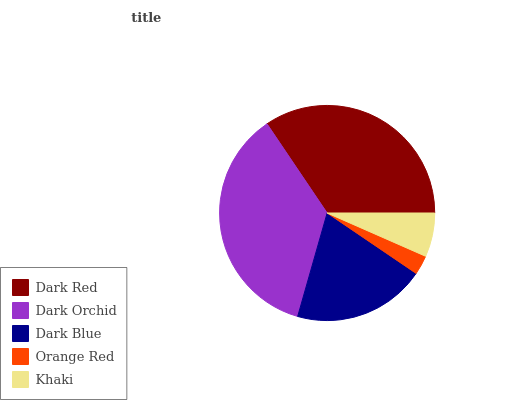Is Orange Red the minimum?
Answer yes or no. Yes. Is Dark Orchid the maximum?
Answer yes or no. Yes. Is Dark Blue the minimum?
Answer yes or no. No. Is Dark Blue the maximum?
Answer yes or no. No. Is Dark Orchid greater than Dark Blue?
Answer yes or no. Yes. Is Dark Blue less than Dark Orchid?
Answer yes or no. Yes. Is Dark Blue greater than Dark Orchid?
Answer yes or no. No. Is Dark Orchid less than Dark Blue?
Answer yes or no. No. Is Dark Blue the high median?
Answer yes or no. Yes. Is Dark Blue the low median?
Answer yes or no. Yes. Is Dark Orchid the high median?
Answer yes or no. No. Is Dark Orchid the low median?
Answer yes or no. No. 